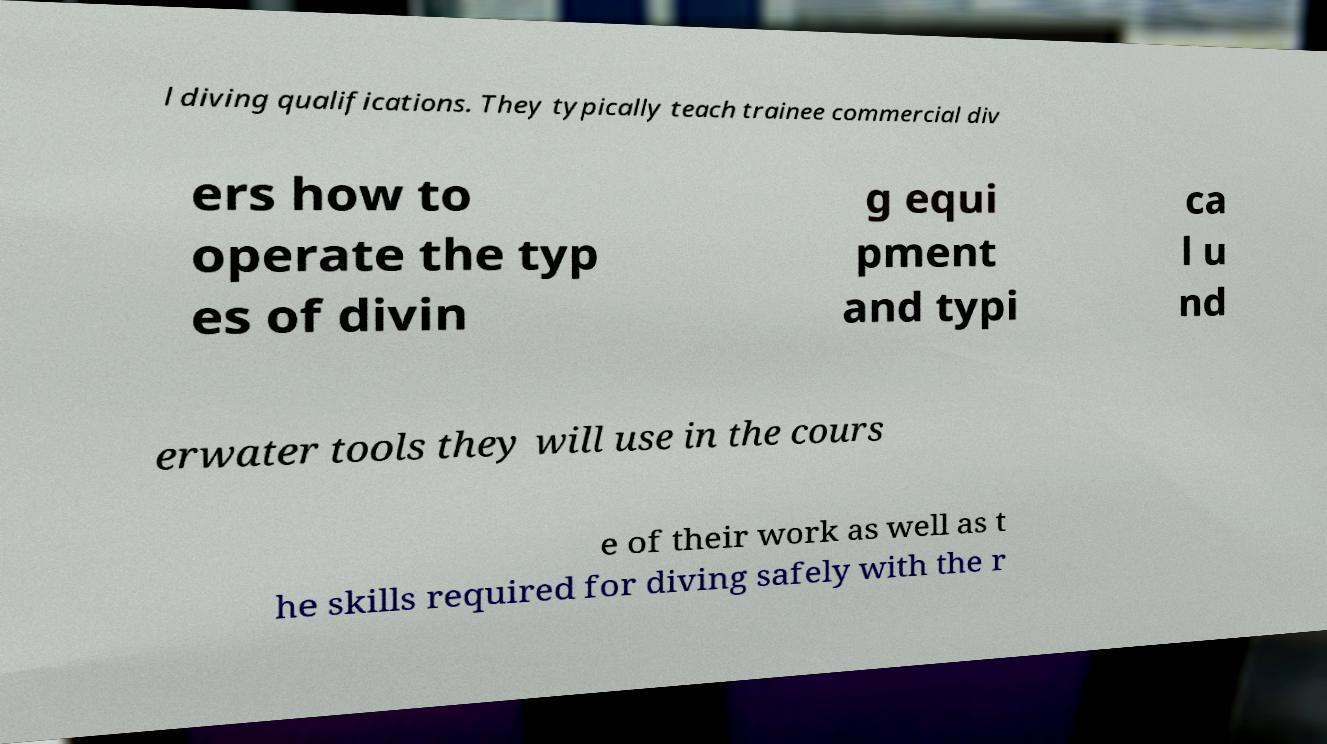For documentation purposes, I need the text within this image transcribed. Could you provide that? l diving qualifications. They typically teach trainee commercial div ers how to operate the typ es of divin g equi pment and typi ca l u nd erwater tools they will use in the cours e of their work as well as t he skills required for diving safely with the r 